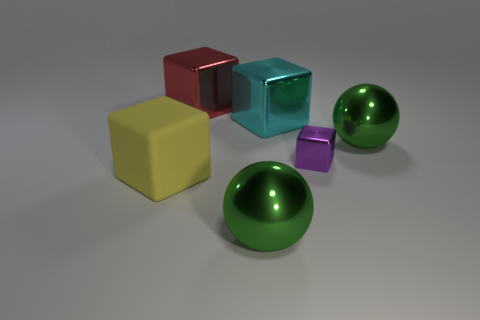Add 1 tiny purple metal blocks. How many objects exist? 7 Subtract all cyan metallic cubes. How many cubes are left? 3 Subtract all yellow blocks. How many blocks are left? 3 Subtract all spheres. How many objects are left? 4 Subtract 4 cubes. How many cubes are left? 0 Subtract all brown spheres. Subtract all red cubes. How many spheres are left? 2 Subtract all blue spheres. How many red blocks are left? 1 Subtract all large purple shiny balls. Subtract all tiny purple things. How many objects are left? 5 Add 3 cyan objects. How many cyan objects are left? 4 Add 2 small purple rubber cylinders. How many small purple rubber cylinders exist? 2 